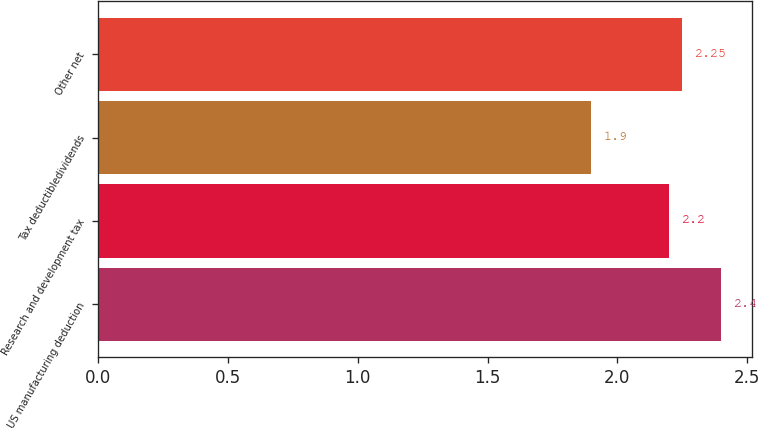Convert chart. <chart><loc_0><loc_0><loc_500><loc_500><bar_chart><fcel>US manufacturing deduction<fcel>Research and development tax<fcel>Tax deductibledividends<fcel>Other net<nl><fcel>2.4<fcel>2.2<fcel>1.9<fcel>2.25<nl></chart> 